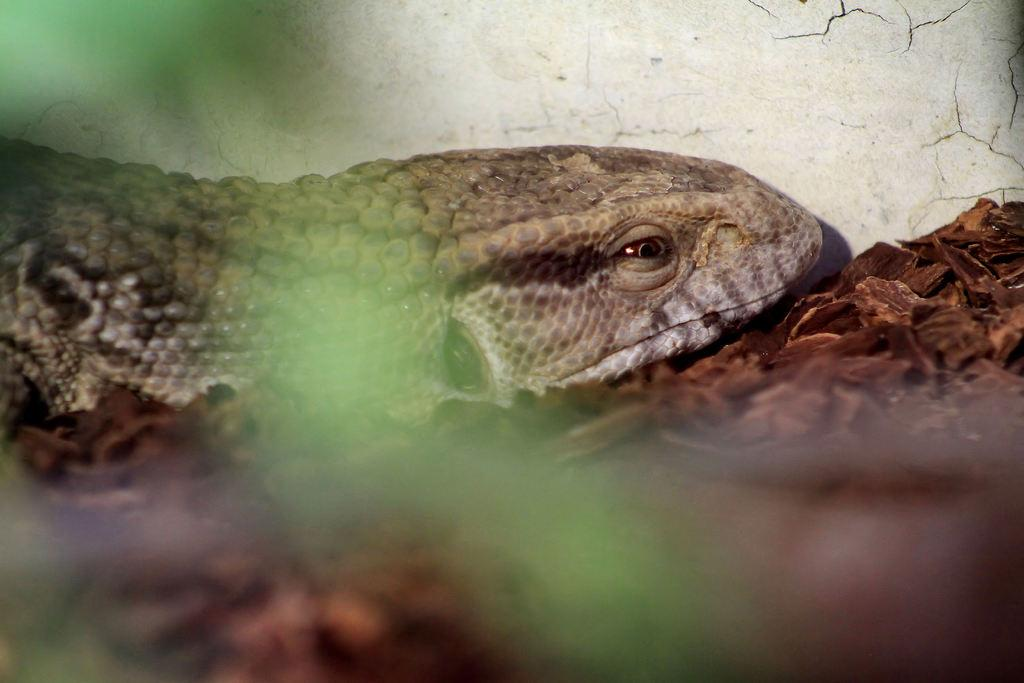What type of animal is in the picture? There is an animal in the picture, but the specific type cannot be determined from the provided facts. What is supporting the animal in the picture? There are wooden pieces under the animal in the picture. What can be seen in the background of the picture? There is a wall in the background of the picture. What type of noise is the animal making in the picture? There is no information about the animal's noise in the picture, so it cannot be determined. Is there a meeting happening in the picture? There is no mention of a meeting or any other human activity in the picture, so it cannot be determined. 